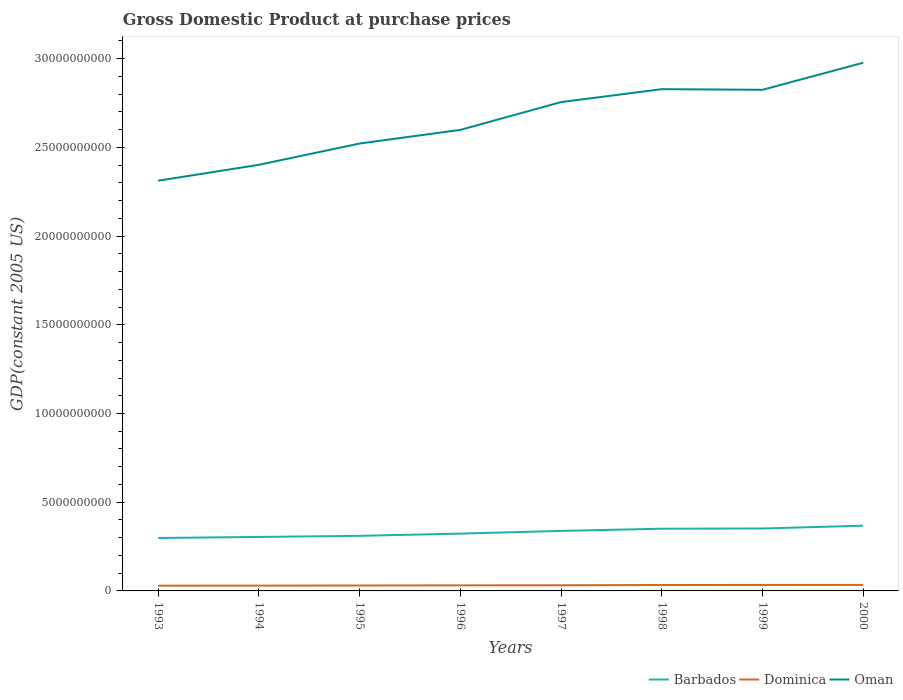Does the line corresponding to Barbados intersect with the line corresponding to Dominica?
Offer a very short reply. No. Across all years, what is the maximum GDP at purchase prices in Oman?
Provide a short and direct response. 2.31e+1. What is the total GDP at purchase prices in Oman in the graph?
Provide a short and direct response. -1.20e+09. What is the difference between the highest and the second highest GDP at purchase prices in Dominica?
Make the answer very short. 4.23e+07. What is the difference between the highest and the lowest GDP at purchase prices in Oman?
Your response must be concise. 4. How many lines are there?
Offer a terse response. 3. Are the values on the major ticks of Y-axis written in scientific E-notation?
Give a very brief answer. No. What is the title of the graph?
Provide a short and direct response. Gross Domestic Product at purchase prices. What is the label or title of the X-axis?
Offer a very short reply. Years. What is the label or title of the Y-axis?
Offer a terse response. GDP(constant 2005 US). What is the GDP(constant 2005 US) in Barbados in 1993?
Give a very brief answer. 2.98e+09. What is the GDP(constant 2005 US) in Dominica in 1993?
Your answer should be very brief. 2.95e+08. What is the GDP(constant 2005 US) of Oman in 1993?
Your answer should be very brief. 2.31e+1. What is the GDP(constant 2005 US) in Barbados in 1994?
Your answer should be compact. 3.04e+09. What is the GDP(constant 2005 US) of Dominica in 1994?
Offer a very short reply. 3.00e+08. What is the GDP(constant 2005 US) of Oman in 1994?
Your answer should be very brief. 2.40e+1. What is the GDP(constant 2005 US) in Barbados in 1995?
Give a very brief answer. 3.10e+09. What is the GDP(constant 2005 US) of Dominica in 1995?
Keep it short and to the point. 3.06e+08. What is the GDP(constant 2005 US) of Oman in 1995?
Your answer should be compact. 2.52e+1. What is the GDP(constant 2005 US) in Barbados in 1996?
Your answer should be very brief. 3.23e+09. What is the GDP(constant 2005 US) of Dominica in 1996?
Offer a very short reply. 3.14e+08. What is the GDP(constant 2005 US) in Oman in 1996?
Make the answer very short. 2.60e+1. What is the GDP(constant 2005 US) in Barbados in 1997?
Give a very brief answer. 3.38e+09. What is the GDP(constant 2005 US) of Dominica in 1997?
Your answer should be very brief. 3.18e+08. What is the GDP(constant 2005 US) of Oman in 1997?
Your answer should be very brief. 2.76e+1. What is the GDP(constant 2005 US) of Barbados in 1998?
Offer a terse response. 3.51e+09. What is the GDP(constant 2005 US) of Dominica in 1998?
Ensure brevity in your answer.  3.34e+08. What is the GDP(constant 2005 US) of Oman in 1998?
Your answer should be very brief. 2.83e+1. What is the GDP(constant 2005 US) of Barbados in 1999?
Keep it short and to the point. 3.52e+09. What is the GDP(constant 2005 US) in Dominica in 1999?
Keep it short and to the point. 3.36e+08. What is the GDP(constant 2005 US) of Oman in 1999?
Your response must be concise. 2.82e+1. What is the GDP(constant 2005 US) in Barbados in 2000?
Ensure brevity in your answer.  3.68e+09. What is the GDP(constant 2005 US) in Dominica in 2000?
Offer a very short reply. 3.38e+08. What is the GDP(constant 2005 US) of Oman in 2000?
Make the answer very short. 2.98e+1. Across all years, what is the maximum GDP(constant 2005 US) of Barbados?
Give a very brief answer. 3.68e+09. Across all years, what is the maximum GDP(constant 2005 US) in Dominica?
Make the answer very short. 3.38e+08. Across all years, what is the maximum GDP(constant 2005 US) of Oman?
Offer a very short reply. 2.98e+1. Across all years, what is the minimum GDP(constant 2005 US) in Barbados?
Make the answer very short. 2.98e+09. Across all years, what is the minimum GDP(constant 2005 US) of Dominica?
Offer a terse response. 2.95e+08. Across all years, what is the minimum GDP(constant 2005 US) in Oman?
Provide a succinct answer. 2.31e+1. What is the total GDP(constant 2005 US) in Barbados in the graph?
Your response must be concise. 2.64e+1. What is the total GDP(constant 2005 US) in Dominica in the graph?
Your response must be concise. 2.54e+09. What is the total GDP(constant 2005 US) in Oman in the graph?
Ensure brevity in your answer.  2.12e+11. What is the difference between the GDP(constant 2005 US) of Barbados in 1993 and that in 1994?
Give a very brief answer. -5.90e+07. What is the difference between the GDP(constant 2005 US) in Dominica in 1993 and that in 1994?
Provide a short and direct response. -4.23e+06. What is the difference between the GDP(constant 2005 US) of Oman in 1993 and that in 1994?
Provide a succinct answer. -8.96e+08. What is the difference between the GDP(constant 2005 US) in Barbados in 1993 and that in 1995?
Keep it short and to the point. -1.22e+08. What is the difference between the GDP(constant 2005 US) in Dominica in 1993 and that in 1995?
Make the answer very short. -1.01e+07. What is the difference between the GDP(constant 2005 US) in Oman in 1993 and that in 1995?
Ensure brevity in your answer.  -2.10e+09. What is the difference between the GDP(constant 2005 US) of Barbados in 1993 and that in 1996?
Your answer should be compact. -2.47e+08. What is the difference between the GDP(constant 2005 US) of Dominica in 1993 and that in 1996?
Keep it short and to the point. -1.82e+07. What is the difference between the GDP(constant 2005 US) of Oman in 1993 and that in 1996?
Offer a very short reply. -2.86e+09. What is the difference between the GDP(constant 2005 US) of Barbados in 1993 and that in 1997?
Your answer should be very brief. -3.98e+08. What is the difference between the GDP(constant 2005 US) of Dominica in 1993 and that in 1997?
Your response must be concise. -2.29e+07. What is the difference between the GDP(constant 2005 US) of Oman in 1993 and that in 1997?
Your answer should be compact. -4.43e+09. What is the difference between the GDP(constant 2005 US) in Barbados in 1993 and that in 1998?
Provide a succinct answer. -5.24e+08. What is the difference between the GDP(constant 2005 US) in Dominica in 1993 and that in 1998?
Your answer should be compact. -3.87e+07. What is the difference between the GDP(constant 2005 US) in Oman in 1993 and that in 1998?
Ensure brevity in your answer.  -5.16e+09. What is the difference between the GDP(constant 2005 US) in Barbados in 1993 and that in 1999?
Your answer should be very brief. -5.35e+08. What is the difference between the GDP(constant 2005 US) of Dominica in 1993 and that in 1999?
Keep it short and to the point. -4.10e+07. What is the difference between the GDP(constant 2005 US) in Oman in 1993 and that in 1999?
Provide a short and direct response. -5.12e+09. What is the difference between the GDP(constant 2005 US) of Barbados in 1993 and that in 2000?
Offer a very short reply. -6.93e+08. What is the difference between the GDP(constant 2005 US) in Dominica in 1993 and that in 2000?
Ensure brevity in your answer.  -4.23e+07. What is the difference between the GDP(constant 2005 US) in Oman in 1993 and that in 2000?
Provide a succinct answer. -6.65e+09. What is the difference between the GDP(constant 2005 US) of Barbados in 1994 and that in 1995?
Give a very brief answer. -6.27e+07. What is the difference between the GDP(constant 2005 US) of Dominica in 1994 and that in 1995?
Give a very brief answer. -5.92e+06. What is the difference between the GDP(constant 2005 US) in Oman in 1994 and that in 1995?
Make the answer very short. -1.20e+09. What is the difference between the GDP(constant 2005 US) in Barbados in 1994 and that in 1996?
Give a very brief answer. -1.88e+08. What is the difference between the GDP(constant 2005 US) in Dominica in 1994 and that in 1996?
Make the answer very short. -1.40e+07. What is the difference between the GDP(constant 2005 US) of Oman in 1994 and that in 1996?
Your response must be concise. -1.97e+09. What is the difference between the GDP(constant 2005 US) in Barbados in 1994 and that in 1997?
Your answer should be compact. -3.39e+08. What is the difference between the GDP(constant 2005 US) in Dominica in 1994 and that in 1997?
Your answer should be very brief. -1.87e+07. What is the difference between the GDP(constant 2005 US) in Oman in 1994 and that in 1997?
Ensure brevity in your answer.  -3.54e+09. What is the difference between the GDP(constant 2005 US) of Barbados in 1994 and that in 1998?
Offer a very short reply. -4.65e+08. What is the difference between the GDP(constant 2005 US) of Dominica in 1994 and that in 1998?
Your response must be concise. -3.45e+07. What is the difference between the GDP(constant 2005 US) in Oman in 1994 and that in 1998?
Your answer should be compact. -4.26e+09. What is the difference between the GDP(constant 2005 US) of Barbados in 1994 and that in 1999?
Provide a succinct answer. -4.76e+08. What is the difference between the GDP(constant 2005 US) in Dominica in 1994 and that in 1999?
Provide a succinct answer. -3.68e+07. What is the difference between the GDP(constant 2005 US) in Oman in 1994 and that in 1999?
Provide a short and direct response. -4.23e+09. What is the difference between the GDP(constant 2005 US) of Barbados in 1994 and that in 2000?
Provide a succinct answer. -6.34e+08. What is the difference between the GDP(constant 2005 US) of Dominica in 1994 and that in 2000?
Ensure brevity in your answer.  -3.81e+07. What is the difference between the GDP(constant 2005 US) in Oman in 1994 and that in 2000?
Give a very brief answer. -5.75e+09. What is the difference between the GDP(constant 2005 US) in Barbados in 1995 and that in 1996?
Give a very brief answer. -1.25e+08. What is the difference between the GDP(constant 2005 US) of Dominica in 1995 and that in 1996?
Offer a very short reply. -8.07e+06. What is the difference between the GDP(constant 2005 US) in Oman in 1995 and that in 1996?
Ensure brevity in your answer.  -7.68e+08. What is the difference between the GDP(constant 2005 US) of Barbados in 1995 and that in 1997?
Provide a succinct answer. -2.77e+08. What is the difference between the GDP(constant 2005 US) in Dominica in 1995 and that in 1997?
Make the answer very short. -1.27e+07. What is the difference between the GDP(constant 2005 US) in Oman in 1995 and that in 1997?
Offer a terse response. -2.34e+09. What is the difference between the GDP(constant 2005 US) of Barbados in 1995 and that in 1998?
Your answer should be very brief. -4.02e+08. What is the difference between the GDP(constant 2005 US) in Dominica in 1995 and that in 1998?
Your response must be concise. -2.86e+07. What is the difference between the GDP(constant 2005 US) of Oman in 1995 and that in 1998?
Provide a succinct answer. -3.06e+09. What is the difference between the GDP(constant 2005 US) of Barbados in 1995 and that in 1999?
Your response must be concise. -4.13e+08. What is the difference between the GDP(constant 2005 US) in Dominica in 1995 and that in 1999?
Offer a very short reply. -3.09e+07. What is the difference between the GDP(constant 2005 US) in Oman in 1995 and that in 1999?
Provide a short and direct response. -3.03e+09. What is the difference between the GDP(constant 2005 US) in Barbados in 1995 and that in 2000?
Your answer should be compact. -5.72e+08. What is the difference between the GDP(constant 2005 US) in Dominica in 1995 and that in 2000?
Keep it short and to the point. -3.21e+07. What is the difference between the GDP(constant 2005 US) in Oman in 1995 and that in 2000?
Give a very brief answer. -4.55e+09. What is the difference between the GDP(constant 2005 US) in Barbados in 1996 and that in 1997?
Your response must be concise. -1.51e+08. What is the difference between the GDP(constant 2005 US) in Dominica in 1996 and that in 1997?
Provide a succinct answer. -4.68e+06. What is the difference between the GDP(constant 2005 US) in Oman in 1996 and that in 1997?
Provide a succinct answer. -1.57e+09. What is the difference between the GDP(constant 2005 US) in Barbados in 1996 and that in 1998?
Keep it short and to the point. -2.77e+08. What is the difference between the GDP(constant 2005 US) in Dominica in 1996 and that in 1998?
Keep it short and to the point. -2.05e+07. What is the difference between the GDP(constant 2005 US) of Oman in 1996 and that in 1998?
Give a very brief answer. -2.30e+09. What is the difference between the GDP(constant 2005 US) in Barbados in 1996 and that in 1999?
Ensure brevity in your answer.  -2.88e+08. What is the difference between the GDP(constant 2005 US) of Dominica in 1996 and that in 1999?
Your response must be concise. -2.28e+07. What is the difference between the GDP(constant 2005 US) in Oman in 1996 and that in 1999?
Give a very brief answer. -2.26e+09. What is the difference between the GDP(constant 2005 US) in Barbados in 1996 and that in 2000?
Ensure brevity in your answer.  -4.46e+08. What is the difference between the GDP(constant 2005 US) in Dominica in 1996 and that in 2000?
Make the answer very short. -2.41e+07. What is the difference between the GDP(constant 2005 US) of Oman in 1996 and that in 2000?
Your answer should be very brief. -3.79e+09. What is the difference between the GDP(constant 2005 US) in Barbados in 1997 and that in 1998?
Keep it short and to the point. -1.25e+08. What is the difference between the GDP(constant 2005 US) in Dominica in 1997 and that in 1998?
Offer a terse response. -1.58e+07. What is the difference between the GDP(constant 2005 US) of Oman in 1997 and that in 1998?
Give a very brief answer. -7.28e+08. What is the difference between the GDP(constant 2005 US) of Barbados in 1997 and that in 1999?
Ensure brevity in your answer.  -1.36e+08. What is the difference between the GDP(constant 2005 US) of Dominica in 1997 and that in 1999?
Your answer should be very brief. -1.81e+07. What is the difference between the GDP(constant 2005 US) in Oman in 1997 and that in 1999?
Your answer should be compact. -6.93e+08. What is the difference between the GDP(constant 2005 US) in Barbados in 1997 and that in 2000?
Your answer should be very brief. -2.95e+08. What is the difference between the GDP(constant 2005 US) of Dominica in 1997 and that in 2000?
Offer a very short reply. -1.94e+07. What is the difference between the GDP(constant 2005 US) of Oman in 1997 and that in 2000?
Give a very brief answer. -2.22e+09. What is the difference between the GDP(constant 2005 US) in Barbados in 1998 and that in 1999?
Ensure brevity in your answer.  -1.11e+07. What is the difference between the GDP(constant 2005 US) of Dominica in 1998 and that in 1999?
Provide a short and direct response. -2.28e+06. What is the difference between the GDP(constant 2005 US) of Oman in 1998 and that in 1999?
Your answer should be very brief. 3.53e+07. What is the difference between the GDP(constant 2005 US) in Barbados in 1998 and that in 2000?
Keep it short and to the point. -1.70e+08. What is the difference between the GDP(constant 2005 US) of Dominica in 1998 and that in 2000?
Your response must be concise. -3.55e+06. What is the difference between the GDP(constant 2005 US) in Oman in 1998 and that in 2000?
Your response must be concise. -1.49e+09. What is the difference between the GDP(constant 2005 US) of Barbados in 1999 and that in 2000?
Provide a succinct answer. -1.59e+08. What is the difference between the GDP(constant 2005 US) in Dominica in 1999 and that in 2000?
Provide a short and direct response. -1.26e+06. What is the difference between the GDP(constant 2005 US) in Oman in 1999 and that in 2000?
Your response must be concise. -1.53e+09. What is the difference between the GDP(constant 2005 US) in Barbados in 1993 and the GDP(constant 2005 US) in Dominica in 1994?
Ensure brevity in your answer.  2.68e+09. What is the difference between the GDP(constant 2005 US) in Barbados in 1993 and the GDP(constant 2005 US) in Oman in 1994?
Your answer should be compact. -2.10e+1. What is the difference between the GDP(constant 2005 US) of Dominica in 1993 and the GDP(constant 2005 US) of Oman in 1994?
Offer a terse response. -2.37e+1. What is the difference between the GDP(constant 2005 US) of Barbados in 1993 and the GDP(constant 2005 US) of Dominica in 1995?
Offer a terse response. 2.68e+09. What is the difference between the GDP(constant 2005 US) in Barbados in 1993 and the GDP(constant 2005 US) in Oman in 1995?
Provide a short and direct response. -2.22e+1. What is the difference between the GDP(constant 2005 US) in Dominica in 1993 and the GDP(constant 2005 US) in Oman in 1995?
Keep it short and to the point. -2.49e+1. What is the difference between the GDP(constant 2005 US) in Barbados in 1993 and the GDP(constant 2005 US) in Dominica in 1996?
Make the answer very short. 2.67e+09. What is the difference between the GDP(constant 2005 US) of Barbados in 1993 and the GDP(constant 2005 US) of Oman in 1996?
Your response must be concise. -2.30e+1. What is the difference between the GDP(constant 2005 US) in Dominica in 1993 and the GDP(constant 2005 US) in Oman in 1996?
Keep it short and to the point. -2.57e+1. What is the difference between the GDP(constant 2005 US) in Barbados in 1993 and the GDP(constant 2005 US) in Dominica in 1997?
Provide a short and direct response. 2.66e+09. What is the difference between the GDP(constant 2005 US) in Barbados in 1993 and the GDP(constant 2005 US) in Oman in 1997?
Provide a succinct answer. -2.46e+1. What is the difference between the GDP(constant 2005 US) of Dominica in 1993 and the GDP(constant 2005 US) of Oman in 1997?
Offer a terse response. -2.73e+1. What is the difference between the GDP(constant 2005 US) of Barbados in 1993 and the GDP(constant 2005 US) of Dominica in 1998?
Your answer should be compact. 2.65e+09. What is the difference between the GDP(constant 2005 US) of Barbados in 1993 and the GDP(constant 2005 US) of Oman in 1998?
Provide a succinct answer. -2.53e+1. What is the difference between the GDP(constant 2005 US) of Dominica in 1993 and the GDP(constant 2005 US) of Oman in 1998?
Offer a terse response. -2.80e+1. What is the difference between the GDP(constant 2005 US) of Barbados in 1993 and the GDP(constant 2005 US) of Dominica in 1999?
Keep it short and to the point. 2.65e+09. What is the difference between the GDP(constant 2005 US) of Barbados in 1993 and the GDP(constant 2005 US) of Oman in 1999?
Provide a short and direct response. -2.53e+1. What is the difference between the GDP(constant 2005 US) of Dominica in 1993 and the GDP(constant 2005 US) of Oman in 1999?
Your answer should be compact. -2.79e+1. What is the difference between the GDP(constant 2005 US) of Barbados in 1993 and the GDP(constant 2005 US) of Dominica in 2000?
Provide a succinct answer. 2.65e+09. What is the difference between the GDP(constant 2005 US) of Barbados in 1993 and the GDP(constant 2005 US) of Oman in 2000?
Ensure brevity in your answer.  -2.68e+1. What is the difference between the GDP(constant 2005 US) of Dominica in 1993 and the GDP(constant 2005 US) of Oman in 2000?
Your answer should be compact. -2.95e+1. What is the difference between the GDP(constant 2005 US) in Barbados in 1994 and the GDP(constant 2005 US) in Dominica in 1995?
Your answer should be compact. 2.74e+09. What is the difference between the GDP(constant 2005 US) in Barbados in 1994 and the GDP(constant 2005 US) in Oman in 1995?
Your answer should be very brief. -2.22e+1. What is the difference between the GDP(constant 2005 US) of Dominica in 1994 and the GDP(constant 2005 US) of Oman in 1995?
Offer a terse response. -2.49e+1. What is the difference between the GDP(constant 2005 US) of Barbados in 1994 and the GDP(constant 2005 US) of Dominica in 1996?
Offer a very short reply. 2.73e+09. What is the difference between the GDP(constant 2005 US) in Barbados in 1994 and the GDP(constant 2005 US) in Oman in 1996?
Provide a short and direct response. -2.29e+1. What is the difference between the GDP(constant 2005 US) of Dominica in 1994 and the GDP(constant 2005 US) of Oman in 1996?
Provide a succinct answer. -2.57e+1. What is the difference between the GDP(constant 2005 US) in Barbados in 1994 and the GDP(constant 2005 US) in Dominica in 1997?
Keep it short and to the point. 2.72e+09. What is the difference between the GDP(constant 2005 US) of Barbados in 1994 and the GDP(constant 2005 US) of Oman in 1997?
Offer a very short reply. -2.45e+1. What is the difference between the GDP(constant 2005 US) of Dominica in 1994 and the GDP(constant 2005 US) of Oman in 1997?
Your answer should be very brief. -2.73e+1. What is the difference between the GDP(constant 2005 US) in Barbados in 1994 and the GDP(constant 2005 US) in Dominica in 1998?
Your response must be concise. 2.71e+09. What is the difference between the GDP(constant 2005 US) in Barbados in 1994 and the GDP(constant 2005 US) in Oman in 1998?
Provide a succinct answer. -2.52e+1. What is the difference between the GDP(constant 2005 US) in Dominica in 1994 and the GDP(constant 2005 US) in Oman in 1998?
Give a very brief answer. -2.80e+1. What is the difference between the GDP(constant 2005 US) in Barbados in 1994 and the GDP(constant 2005 US) in Dominica in 1999?
Ensure brevity in your answer.  2.71e+09. What is the difference between the GDP(constant 2005 US) of Barbados in 1994 and the GDP(constant 2005 US) of Oman in 1999?
Give a very brief answer. -2.52e+1. What is the difference between the GDP(constant 2005 US) of Dominica in 1994 and the GDP(constant 2005 US) of Oman in 1999?
Your response must be concise. -2.79e+1. What is the difference between the GDP(constant 2005 US) of Barbados in 1994 and the GDP(constant 2005 US) of Dominica in 2000?
Make the answer very short. 2.70e+09. What is the difference between the GDP(constant 2005 US) in Barbados in 1994 and the GDP(constant 2005 US) in Oman in 2000?
Your answer should be compact. -2.67e+1. What is the difference between the GDP(constant 2005 US) in Dominica in 1994 and the GDP(constant 2005 US) in Oman in 2000?
Make the answer very short. -2.95e+1. What is the difference between the GDP(constant 2005 US) of Barbados in 1995 and the GDP(constant 2005 US) of Dominica in 1996?
Your answer should be compact. 2.79e+09. What is the difference between the GDP(constant 2005 US) of Barbados in 1995 and the GDP(constant 2005 US) of Oman in 1996?
Provide a succinct answer. -2.29e+1. What is the difference between the GDP(constant 2005 US) of Dominica in 1995 and the GDP(constant 2005 US) of Oman in 1996?
Provide a succinct answer. -2.57e+1. What is the difference between the GDP(constant 2005 US) in Barbados in 1995 and the GDP(constant 2005 US) in Dominica in 1997?
Offer a terse response. 2.79e+09. What is the difference between the GDP(constant 2005 US) in Barbados in 1995 and the GDP(constant 2005 US) in Oman in 1997?
Offer a terse response. -2.44e+1. What is the difference between the GDP(constant 2005 US) in Dominica in 1995 and the GDP(constant 2005 US) in Oman in 1997?
Your answer should be very brief. -2.72e+1. What is the difference between the GDP(constant 2005 US) in Barbados in 1995 and the GDP(constant 2005 US) in Dominica in 1998?
Provide a succinct answer. 2.77e+09. What is the difference between the GDP(constant 2005 US) in Barbados in 1995 and the GDP(constant 2005 US) in Oman in 1998?
Offer a very short reply. -2.52e+1. What is the difference between the GDP(constant 2005 US) of Dominica in 1995 and the GDP(constant 2005 US) of Oman in 1998?
Your response must be concise. -2.80e+1. What is the difference between the GDP(constant 2005 US) in Barbados in 1995 and the GDP(constant 2005 US) in Dominica in 1999?
Give a very brief answer. 2.77e+09. What is the difference between the GDP(constant 2005 US) of Barbados in 1995 and the GDP(constant 2005 US) of Oman in 1999?
Offer a terse response. -2.51e+1. What is the difference between the GDP(constant 2005 US) of Dominica in 1995 and the GDP(constant 2005 US) of Oman in 1999?
Ensure brevity in your answer.  -2.79e+1. What is the difference between the GDP(constant 2005 US) of Barbados in 1995 and the GDP(constant 2005 US) of Dominica in 2000?
Your response must be concise. 2.77e+09. What is the difference between the GDP(constant 2005 US) in Barbados in 1995 and the GDP(constant 2005 US) in Oman in 2000?
Give a very brief answer. -2.67e+1. What is the difference between the GDP(constant 2005 US) in Dominica in 1995 and the GDP(constant 2005 US) in Oman in 2000?
Provide a succinct answer. -2.95e+1. What is the difference between the GDP(constant 2005 US) of Barbados in 1996 and the GDP(constant 2005 US) of Dominica in 1997?
Ensure brevity in your answer.  2.91e+09. What is the difference between the GDP(constant 2005 US) of Barbados in 1996 and the GDP(constant 2005 US) of Oman in 1997?
Give a very brief answer. -2.43e+1. What is the difference between the GDP(constant 2005 US) in Dominica in 1996 and the GDP(constant 2005 US) in Oman in 1997?
Keep it short and to the point. -2.72e+1. What is the difference between the GDP(constant 2005 US) in Barbados in 1996 and the GDP(constant 2005 US) in Dominica in 1998?
Give a very brief answer. 2.90e+09. What is the difference between the GDP(constant 2005 US) in Barbados in 1996 and the GDP(constant 2005 US) in Oman in 1998?
Ensure brevity in your answer.  -2.50e+1. What is the difference between the GDP(constant 2005 US) of Dominica in 1996 and the GDP(constant 2005 US) of Oman in 1998?
Your response must be concise. -2.80e+1. What is the difference between the GDP(constant 2005 US) in Barbados in 1996 and the GDP(constant 2005 US) in Dominica in 1999?
Give a very brief answer. 2.89e+09. What is the difference between the GDP(constant 2005 US) of Barbados in 1996 and the GDP(constant 2005 US) of Oman in 1999?
Make the answer very short. -2.50e+1. What is the difference between the GDP(constant 2005 US) of Dominica in 1996 and the GDP(constant 2005 US) of Oman in 1999?
Your response must be concise. -2.79e+1. What is the difference between the GDP(constant 2005 US) of Barbados in 1996 and the GDP(constant 2005 US) of Dominica in 2000?
Your response must be concise. 2.89e+09. What is the difference between the GDP(constant 2005 US) of Barbados in 1996 and the GDP(constant 2005 US) of Oman in 2000?
Ensure brevity in your answer.  -2.65e+1. What is the difference between the GDP(constant 2005 US) in Dominica in 1996 and the GDP(constant 2005 US) in Oman in 2000?
Make the answer very short. -2.95e+1. What is the difference between the GDP(constant 2005 US) in Barbados in 1997 and the GDP(constant 2005 US) in Dominica in 1998?
Ensure brevity in your answer.  3.05e+09. What is the difference between the GDP(constant 2005 US) in Barbados in 1997 and the GDP(constant 2005 US) in Oman in 1998?
Your response must be concise. -2.49e+1. What is the difference between the GDP(constant 2005 US) in Dominica in 1997 and the GDP(constant 2005 US) in Oman in 1998?
Your answer should be compact. -2.80e+1. What is the difference between the GDP(constant 2005 US) of Barbados in 1997 and the GDP(constant 2005 US) of Dominica in 1999?
Your answer should be very brief. 3.04e+09. What is the difference between the GDP(constant 2005 US) in Barbados in 1997 and the GDP(constant 2005 US) in Oman in 1999?
Provide a succinct answer. -2.49e+1. What is the difference between the GDP(constant 2005 US) in Dominica in 1997 and the GDP(constant 2005 US) in Oman in 1999?
Your answer should be compact. -2.79e+1. What is the difference between the GDP(constant 2005 US) in Barbados in 1997 and the GDP(constant 2005 US) in Dominica in 2000?
Keep it short and to the point. 3.04e+09. What is the difference between the GDP(constant 2005 US) in Barbados in 1997 and the GDP(constant 2005 US) in Oman in 2000?
Your answer should be compact. -2.64e+1. What is the difference between the GDP(constant 2005 US) in Dominica in 1997 and the GDP(constant 2005 US) in Oman in 2000?
Provide a succinct answer. -2.95e+1. What is the difference between the GDP(constant 2005 US) in Barbados in 1998 and the GDP(constant 2005 US) in Dominica in 1999?
Offer a very short reply. 3.17e+09. What is the difference between the GDP(constant 2005 US) of Barbados in 1998 and the GDP(constant 2005 US) of Oman in 1999?
Make the answer very short. -2.47e+1. What is the difference between the GDP(constant 2005 US) of Dominica in 1998 and the GDP(constant 2005 US) of Oman in 1999?
Make the answer very short. -2.79e+1. What is the difference between the GDP(constant 2005 US) in Barbados in 1998 and the GDP(constant 2005 US) in Dominica in 2000?
Your answer should be very brief. 3.17e+09. What is the difference between the GDP(constant 2005 US) of Barbados in 1998 and the GDP(constant 2005 US) of Oman in 2000?
Provide a short and direct response. -2.63e+1. What is the difference between the GDP(constant 2005 US) in Dominica in 1998 and the GDP(constant 2005 US) in Oman in 2000?
Make the answer very short. -2.94e+1. What is the difference between the GDP(constant 2005 US) of Barbados in 1999 and the GDP(constant 2005 US) of Dominica in 2000?
Make the answer very short. 3.18e+09. What is the difference between the GDP(constant 2005 US) in Barbados in 1999 and the GDP(constant 2005 US) in Oman in 2000?
Your response must be concise. -2.63e+1. What is the difference between the GDP(constant 2005 US) of Dominica in 1999 and the GDP(constant 2005 US) of Oman in 2000?
Offer a terse response. -2.94e+1. What is the average GDP(constant 2005 US) of Barbados per year?
Give a very brief answer. 3.31e+09. What is the average GDP(constant 2005 US) in Dominica per year?
Keep it short and to the point. 3.18e+08. What is the average GDP(constant 2005 US) in Oman per year?
Your answer should be very brief. 2.65e+1. In the year 1993, what is the difference between the GDP(constant 2005 US) of Barbados and GDP(constant 2005 US) of Dominica?
Make the answer very short. 2.69e+09. In the year 1993, what is the difference between the GDP(constant 2005 US) of Barbados and GDP(constant 2005 US) of Oman?
Give a very brief answer. -2.01e+1. In the year 1993, what is the difference between the GDP(constant 2005 US) in Dominica and GDP(constant 2005 US) in Oman?
Offer a very short reply. -2.28e+1. In the year 1994, what is the difference between the GDP(constant 2005 US) of Barbados and GDP(constant 2005 US) of Dominica?
Provide a succinct answer. 2.74e+09. In the year 1994, what is the difference between the GDP(constant 2005 US) in Barbados and GDP(constant 2005 US) in Oman?
Offer a terse response. -2.10e+1. In the year 1994, what is the difference between the GDP(constant 2005 US) in Dominica and GDP(constant 2005 US) in Oman?
Your answer should be compact. -2.37e+1. In the year 1995, what is the difference between the GDP(constant 2005 US) of Barbados and GDP(constant 2005 US) of Dominica?
Make the answer very short. 2.80e+09. In the year 1995, what is the difference between the GDP(constant 2005 US) of Barbados and GDP(constant 2005 US) of Oman?
Provide a succinct answer. -2.21e+1. In the year 1995, what is the difference between the GDP(constant 2005 US) of Dominica and GDP(constant 2005 US) of Oman?
Provide a short and direct response. -2.49e+1. In the year 1996, what is the difference between the GDP(constant 2005 US) in Barbados and GDP(constant 2005 US) in Dominica?
Offer a terse response. 2.92e+09. In the year 1996, what is the difference between the GDP(constant 2005 US) in Barbados and GDP(constant 2005 US) in Oman?
Give a very brief answer. -2.28e+1. In the year 1996, what is the difference between the GDP(constant 2005 US) of Dominica and GDP(constant 2005 US) of Oman?
Ensure brevity in your answer.  -2.57e+1. In the year 1997, what is the difference between the GDP(constant 2005 US) in Barbados and GDP(constant 2005 US) in Dominica?
Give a very brief answer. 3.06e+09. In the year 1997, what is the difference between the GDP(constant 2005 US) in Barbados and GDP(constant 2005 US) in Oman?
Provide a succinct answer. -2.42e+1. In the year 1997, what is the difference between the GDP(constant 2005 US) of Dominica and GDP(constant 2005 US) of Oman?
Your response must be concise. -2.72e+1. In the year 1998, what is the difference between the GDP(constant 2005 US) of Barbados and GDP(constant 2005 US) of Dominica?
Ensure brevity in your answer.  3.17e+09. In the year 1998, what is the difference between the GDP(constant 2005 US) of Barbados and GDP(constant 2005 US) of Oman?
Provide a succinct answer. -2.48e+1. In the year 1998, what is the difference between the GDP(constant 2005 US) in Dominica and GDP(constant 2005 US) in Oman?
Your answer should be compact. -2.79e+1. In the year 1999, what is the difference between the GDP(constant 2005 US) in Barbados and GDP(constant 2005 US) in Dominica?
Provide a succinct answer. 3.18e+09. In the year 1999, what is the difference between the GDP(constant 2005 US) of Barbados and GDP(constant 2005 US) of Oman?
Your answer should be compact. -2.47e+1. In the year 1999, what is the difference between the GDP(constant 2005 US) in Dominica and GDP(constant 2005 US) in Oman?
Your answer should be very brief. -2.79e+1. In the year 2000, what is the difference between the GDP(constant 2005 US) of Barbados and GDP(constant 2005 US) of Dominica?
Keep it short and to the point. 3.34e+09. In the year 2000, what is the difference between the GDP(constant 2005 US) of Barbados and GDP(constant 2005 US) of Oman?
Give a very brief answer. -2.61e+1. In the year 2000, what is the difference between the GDP(constant 2005 US) in Dominica and GDP(constant 2005 US) in Oman?
Provide a succinct answer. -2.94e+1. What is the ratio of the GDP(constant 2005 US) of Barbados in 1993 to that in 1994?
Offer a terse response. 0.98. What is the ratio of the GDP(constant 2005 US) of Dominica in 1993 to that in 1994?
Make the answer very short. 0.99. What is the ratio of the GDP(constant 2005 US) of Oman in 1993 to that in 1994?
Provide a short and direct response. 0.96. What is the ratio of the GDP(constant 2005 US) of Barbados in 1993 to that in 1995?
Keep it short and to the point. 0.96. What is the ratio of the GDP(constant 2005 US) of Dominica in 1993 to that in 1995?
Keep it short and to the point. 0.97. What is the ratio of the GDP(constant 2005 US) of Oman in 1993 to that in 1995?
Keep it short and to the point. 0.92. What is the ratio of the GDP(constant 2005 US) in Barbados in 1993 to that in 1996?
Offer a terse response. 0.92. What is the ratio of the GDP(constant 2005 US) of Dominica in 1993 to that in 1996?
Make the answer very short. 0.94. What is the ratio of the GDP(constant 2005 US) in Oman in 1993 to that in 1996?
Offer a very short reply. 0.89. What is the ratio of the GDP(constant 2005 US) in Barbados in 1993 to that in 1997?
Keep it short and to the point. 0.88. What is the ratio of the GDP(constant 2005 US) in Dominica in 1993 to that in 1997?
Offer a terse response. 0.93. What is the ratio of the GDP(constant 2005 US) in Oman in 1993 to that in 1997?
Offer a very short reply. 0.84. What is the ratio of the GDP(constant 2005 US) of Barbados in 1993 to that in 1998?
Offer a very short reply. 0.85. What is the ratio of the GDP(constant 2005 US) of Dominica in 1993 to that in 1998?
Your response must be concise. 0.88. What is the ratio of the GDP(constant 2005 US) of Oman in 1993 to that in 1998?
Provide a succinct answer. 0.82. What is the ratio of the GDP(constant 2005 US) of Barbados in 1993 to that in 1999?
Your answer should be very brief. 0.85. What is the ratio of the GDP(constant 2005 US) in Dominica in 1993 to that in 1999?
Keep it short and to the point. 0.88. What is the ratio of the GDP(constant 2005 US) in Oman in 1993 to that in 1999?
Provide a short and direct response. 0.82. What is the ratio of the GDP(constant 2005 US) in Barbados in 1993 to that in 2000?
Make the answer very short. 0.81. What is the ratio of the GDP(constant 2005 US) of Dominica in 1993 to that in 2000?
Ensure brevity in your answer.  0.87. What is the ratio of the GDP(constant 2005 US) of Oman in 1993 to that in 2000?
Give a very brief answer. 0.78. What is the ratio of the GDP(constant 2005 US) of Barbados in 1994 to that in 1995?
Give a very brief answer. 0.98. What is the ratio of the GDP(constant 2005 US) in Dominica in 1994 to that in 1995?
Make the answer very short. 0.98. What is the ratio of the GDP(constant 2005 US) in Barbados in 1994 to that in 1996?
Offer a terse response. 0.94. What is the ratio of the GDP(constant 2005 US) in Dominica in 1994 to that in 1996?
Offer a very short reply. 0.96. What is the ratio of the GDP(constant 2005 US) of Oman in 1994 to that in 1996?
Provide a succinct answer. 0.92. What is the ratio of the GDP(constant 2005 US) in Barbados in 1994 to that in 1997?
Your answer should be compact. 0.9. What is the ratio of the GDP(constant 2005 US) in Dominica in 1994 to that in 1997?
Make the answer very short. 0.94. What is the ratio of the GDP(constant 2005 US) in Oman in 1994 to that in 1997?
Your answer should be compact. 0.87. What is the ratio of the GDP(constant 2005 US) of Barbados in 1994 to that in 1998?
Offer a very short reply. 0.87. What is the ratio of the GDP(constant 2005 US) in Dominica in 1994 to that in 1998?
Ensure brevity in your answer.  0.9. What is the ratio of the GDP(constant 2005 US) of Oman in 1994 to that in 1998?
Provide a short and direct response. 0.85. What is the ratio of the GDP(constant 2005 US) of Barbados in 1994 to that in 1999?
Provide a short and direct response. 0.86. What is the ratio of the GDP(constant 2005 US) in Dominica in 1994 to that in 1999?
Provide a short and direct response. 0.89. What is the ratio of the GDP(constant 2005 US) of Oman in 1994 to that in 1999?
Provide a succinct answer. 0.85. What is the ratio of the GDP(constant 2005 US) in Barbados in 1994 to that in 2000?
Provide a short and direct response. 0.83. What is the ratio of the GDP(constant 2005 US) in Dominica in 1994 to that in 2000?
Your answer should be compact. 0.89. What is the ratio of the GDP(constant 2005 US) in Oman in 1994 to that in 2000?
Keep it short and to the point. 0.81. What is the ratio of the GDP(constant 2005 US) in Barbados in 1995 to that in 1996?
Keep it short and to the point. 0.96. What is the ratio of the GDP(constant 2005 US) of Dominica in 1995 to that in 1996?
Provide a short and direct response. 0.97. What is the ratio of the GDP(constant 2005 US) of Oman in 1995 to that in 1996?
Your answer should be compact. 0.97. What is the ratio of the GDP(constant 2005 US) of Barbados in 1995 to that in 1997?
Your answer should be compact. 0.92. What is the ratio of the GDP(constant 2005 US) of Oman in 1995 to that in 1997?
Your answer should be compact. 0.92. What is the ratio of the GDP(constant 2005 US) of Barbados in 1995 to that in 1998?
Ensure brevity in your answer.  0.89. What is the ratio of the GDP(constant 2005 US) in Dominica in 1995 to that in 1998?
Give a very brief answer. 0.91. What is the ratio of the GDP(constant 2005 US) in Oman in 1995 to that in 1998?
Provide a short and direct response. 0.89. What is the ratio of the GDP(constant 2005 US) in Barbados in 1995 to that in 1999?
Ensure brevity in your answer.  0.88. What is the ratio of the GDP(constant 2005 US) in Dominica in 1995 to that in 1999?
Provide a short and direct response. 0.91. What is the ratio of the GDP(constant 2005 US) of Oman in 1995 to that in 1999?
Keep it short and to the point. 0.89. What is the ratio of the GDP(constant 2005 US) in Barbados in 1995 to that in 2000?
Your answer should be very brief. 0.84. What is the ratio of the GDP(constant 2005 US) in Dominica in 1995 to that in 2000?
Your answer should be very brief. 0.9. What is the ratio of the GDP(constant 2005 US) of Oman in 1995 to that in 2000?
Make the answer very short. 0.85. What is the ratio of the GDP(constant 2005 US) in Barbados in 1996 to that in 1997?
Your answer should be very brief. 0.96. What is the ratio of the GDP(constant 2005 US) of Dominica in 1996 to that in 1997?
Provide a succinct answer. 0.99. What is the ratio of the GDP(constant 2005 US) of Oman in 1996 to that in 1997?
Offer a very short reply. 0.94. What is the ratio of the GDP(constant 2005 US) in Barbados in 1996 to that in 1998?
Provide a short and direct response. 0.92. What is the ratio of the GDP(constant 2005 US) of Dominica in 1996 to that in 1998?
Your answer should be very brief. 0.94. What is the ratio of the GDP(constant 2005 US) of Oman in 1996 to that in 1998?
Offer a very short reply. 0.92. What is the ratio of the GDP(constant 2005 US) of Barbados in 1996 to that in 1999?
Give a very brief answer. 0.92. What is the ratio of the GDP(constant 2005 US) of Dominica in 1996 to that in 1999?
Your answer should be compact. 0.93. What is the ratio of the GDP(constant 2005 US) in Barbados in 1996 to that in 2000?
Your answer should be very brief. 0.88. What is the ratio of the GDP(constant 2005 US) in Dominica in 1996 to that in 2000?
Make the answer very short. 0.93. What is the ratio of the GDP(constant 2005 US) of Oman in 1996 to that in 2000?
Offer a terse response. 0.87. What is the ratio of the GDP(constant 2005 US) of Barbados in 1997 to that in 1998?
Offer a very short reply. 0.96. What is the ratio of the GDP(constant 2005 US) of Dominica in 1997 to that in 1998?
Offer a very short reply. 0.95. What is the ratio of the GDP(constant 2005 US) in Oman in 1997 to that in 1998?
Your answer should be very brief. 0.97. What is the ratio of the GDP(constant 2005 US) in Barbados in 1997 to that in 1999?
Ensure brevity in your answer.  0.96. What is the ratio of the GDP(constant 2005 US) of Dominica in 1997 to that in 1999?
Your response must be concise. 0.95. What is the ratio of the GDP(constant 2005 US) in Oman in 1997 to that in 1999?
Your answer should be very brief. 0.98. What is the ratio of the GDP(constant 2005 US) of Barbados in 1997 to that in 2000?
Give a very brief answer. 0.92. What is the ratio of the GDP(constant 2005 US) in Dominica in 1997 to that in 2000?
Your answer should be very brief. 0.94. What is the ratio of the GDP(constant 2005 US) of Oman in 1997 to that in 2000?
Your response must be concise. 0.93. What is the ratio of the GDP(constant 2005 US) of Oman in 1998 to that in 1999?
Your answer should be very brief. 1. What is the ratio of the GDP(constant 2005 US) of Barbados in 1998 to that in 2000?
Make the answer very short. 0.95. What is the ratio of the GDP(constant 2005 US) of Oman in 1998 to that in 2000?
Give a very brief answer. 0.95. What is the ratio of the GDP(constant 2005 US) of Barbados in 1999 to that in 2000?
Keep it short and to the point. 0.96. What is the ratio of the GDP(constant 2005 US) of Oman in 1999 to that in 2000?
Ensure brevity in your answer.  0.95. What is the difference between the highest and the second highest GDP(constant 2005 US) of Barbados?
Offer a very short reply. 1.59e+08. What is the difference between the highest and the second highest GDP(constant 2005 US) in Dominica?
Ensure brevity in your answer.  1.26e+06. What is the difference between the highest and the second highest GDP(constant 2005 US) of Oman?
Your answer should be compact. 1.49e+09. What is the difference between the highest and the lowest GDP(constant 2005 US) in Barbados?
Offer a terse response. 6.93e+08. What is the difference between the highest and the lowest GDP(constant 2005 US) of Dominica?
Your answer should be compact. 4.23e+07. What is the difference between the highest and the lowest GDP(constant 2005 US) of Oman?
Keep it short and to the point. 6.65e+09. 